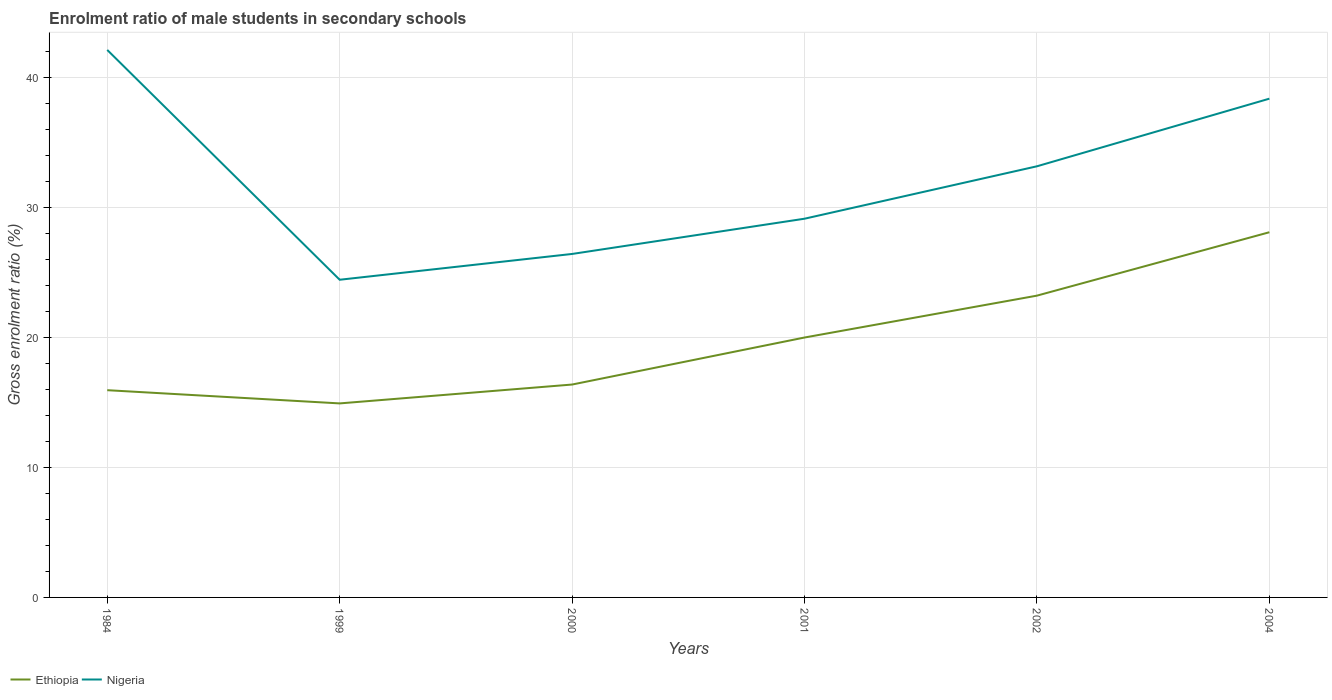How many different coloured lines are there?
Offer a very short reply. 2. Does the line corresponding to Nigeria intersect with the line corresponding to Ethiopia?
Make the answer very short. No. Across all years, what is the maximum enrolment ratio of male students in secondary schools in Nigeria?
Offer a very short reply. 24.42. What is the total enrolment ratio of male students in secondary schools in Ethiopia in the graph?
Ensure brevity in your answer.  -4.05. What is the difference between the highest and the second highest enrolment ratio of male students in secondary schools in Nigeria?
Offer a terse response. 17.67. How many lines are there?
Your response must be concise. 2. How many years are there in the graph?
Your answer should be very brief. 6. What is the difference between two consecutive major ticks on the Y-axis?
Offer a terse response. 10. Does the graph contain any zero values?
Your answer should be very brief. No. Where does the legend appear in the graph?
Your answer should be very brief. Bottom left. How many legend labels are there?
Provide a succinct answer. 2. What is the title of the graph?
Give a very brief answer. Enrolment ratio of male students in secondary schools. What is the label or title of the X-axis?
Your answer should be compact. Years. What is the Gross enrolment ratio (%) of Ethiopia in 1984?
Offer a very short reply. 15.93. What is the Gross enrolment ratio (%) of Nigeria in 1984?
Offer a very short reply. 42.09. What is the Gross enrolment ratio (%) in Ethiopia in 1999?
Provide a succinct answer. 14.92. What is the Gross enrolment ratio (%) in Nigeria in 1999?
Your answer should be very brief. 24.42. What is the Gross enrolment ratio (%) in Ethiopia in 2000?
Give a very brief answer. 16.37. What is the Gross enrolment ratio (%) of Nigeria in 2000?
Offer a terse response. 26.4. What is the Gross enrolment ratio (%) of Ethiopia in 2001?
Offer a very short reply. 19.98. What is the Gross enrolment ratio (%) in Nigeria in 2001?
Your response must be concise. 29.11. What is the Gross enrolment ratio (%) of Ethiopia in 2002?
Ensure brevity in your answer.  23.2. What is the Gross enrolment ratio (%) of Nigeria in 2002?
Offer a very short reply. 33.14. What is the Gross enrolment ratio (%) in Ethiopia in 2004?
Ensure brevity in your answer.  28.07. What is the Gross enrolment ratio (%) in Nigeria in 2004?
Your answer should be compact. 38.34. Across all years, what is the maximum Gross enrolment ratio (%) of Ethiopia?
Provide a short and direct response. 28.07. Across all years, what is the maximum Gross enrolment ratio (%) of Nigeria?
Offer a terse response. 42.09. Across all years, what is the minimum Gross enrolment ratio (%) of Ethiopia?
Provide a short and direct response. 14.92. Across all years, what is the minimum Gross enrolment ratio (%) of Nigeria?
Ensure brevity in your answer.  24.42. What is the total Gross enrolment ratio (%) in Ethiopia in the graph?
Provide a short and direct response. 118.46. What is the total Gross enrolment ratio (%) of Nigeria in the graph?
Your response must be concise. 193.51. What is the difference between the Gross enrolment ratio (%) of Ethiopia in 1984 and that in 1999?
Provide a short and direct response. 1.02. What is the difference between the Gross enrolment ratio (%) in Nigeria in 1984 and that in 1999?
Your answer should be very brief. 17.67. What is the difference between the Gross enrolment ratio (%) in Ethiopia in 1984 and that in 2000?
Make the answer very short. -0.43. What is the difference between the Gross enrolment ratio (%) of Nigeria in 1984 and that in 2000?
Provide a succinct answer. 15.68. What is the difference between the Gross enrolment ratio (%) in Ethiopia in 1984 and that in 2001?
Offer a very short reply. -4.05. What is the difference between the Gross enrolment ratio (%) of Nigeria in 1984 and that in 2001?
Ensure brevity in your answer.  12.98. What is the difference between the Gross enrolment ratio (%) in Ethiopia in 1984 and that in 2002?
Make the answer very short. -7.27. What is the difference between the Gross enrolment ratio (%) in Nigeria in 1984 and that in 2002?
Your answer should be compact. 8.95. What is the difference between the Gross enrolment ratio (%) in Ethiopia in 1984 and that in 2004?
Provide a succinct answer. -12.14. What is the difference between the Gross enrolment ratio (%) of Nigeria in 1984 and that in 2004?
Offer a terse response. 3.75. What is the difference between the Gross enrolment ratio (%) in Ethiopia in 1999 and that in 2000?
Provide a succinct answer. -1.45. What is the difference between the Gross enrolment ratio (%) of Nigeria in 1999 and that in 2000?
Provide a succinct answer. -1.98. What is the difference between the Gross enrolment ratio (%) in Ethiopia in 1999 and that in 2001?
Your answer should be very brief. -5.06. What is the difference between the Gross enrolment ratio (%) of Nigeria in 1999 and that in 2001?
Your response must be concise. -4.69. What is the difference between the Gross enrolment ratio (%) in Ethiopia in 1999 and that in 2002?
Make the answer very short. -8.28. What is the difference between the Gross enrolment ratio (%) of Nigeria in 1999 and that in 2002?
Provide a succinct answer. -8.72. What is the difference between the Gross enrolment ratio (%) of Ethiopia in 1999 and that in 2004?
Provide a short and direct response. -13.16. What is the difference between the Gross enrolment ratio (%) of Nigeria in 1999 and that in 2004?
Your answer should be very brief. -13.92. What is the difference between the Gross enrolment ratio (%) of Ethiopia in 2000 and that in 2001?
Your answer should be compact. -3.61. What is the difference between the Gross enrolment ratio (%) in Nigeria in 2000 and that in 2001?
Provide a succinct answer. -2.71. What is the difference between the Gross enrolment ratio (%) of Ethiopia in 2000 and that in 2002?
Give a very brief answer. -6.83. What is the difference between the Gross enrolment ratio (%) in Nigeria in 2000 and that in 2002?
Provide a succinct answer. -6.74. What is the difference between the Gross enrolment ratio (%) in Ethiopia in 2000 and that in 2004?
Your answer should be very brief. -11.71. What is the difference between the Gross enrolment ratio (%) of Nigeria in 2000 and that in 2004?
Give a very brief answer. -11.94. What is the difference between the Gross enrolment ratio (%) in Ethiopia in 2001 and that in 2002?
Give a very brief answer. -3.22. What is the difference between the Gross enrolment ratio (%) of Nigeria in 2001 and that in 2002?
Offer a very short reply. -4.03. What is the difference between the Gross enrolment ratio (%) in Ethiopia in 2001 and that in 2004?
Make the answer very short. -8.09. What is the difference between the Gross enrolment ratio (%) of Nigeria in 2001 and that in 2004?
Your response must be concise. -9.23. What is the difference between the Gross enrolment ratio (%) in Ethiopia in 2002 and that in 2004?
Your response must be concise. -4.87. What is the difference between the Gross enrolment ratio (%) in Nigeria in 2002 and that in 2004?
Offer a very short reply. -5.2. What is the difference between the Gross enrolment ratio (%) in Ethiopia in 1984 and the Gross enrolment ratio (%) in Nigeria in 1999?
Your response must be concise. -8.49. What is the difference between the Gross enrolment ratio (%) of Ethiopia in 1984 and the Gross enrolment ratio (%) of Nigeria in 2000?
Your response must be concise. -10.47. What is the difference between the Gross enrolment ratio (%) in Ethiopia in 1984 and the Gross enrolment ratio (%) in Nigeria in 2001?
Your response must be concise. -13.18. What is the difference between the Gross enrolment ratio (%) of Ethiopia in 1984 and the Gross enrolment ratio (%) of Nigeria in 2002?
Offer a very short reply. -17.21. What is the difference between the Gross enrolment ratio (%) in Ethiopia in 1984 and the Gross enrolment ratio (%) in Nigeria in 2004?
Offer a terse response. -22.41. What is the difference between the Gross enrolment ratio (%) in Ethiopia in 1999 and the Gross enrolment ratio (%) in Nigeria in 2000?
Keep it short and to the point. -11.49. What is the difference between the Gross enrolment ratio (%) of Ethiopia in 1999 and the Gross enrolment ratio (%) of Nigeria in 2001?
Provide a short and direct response. -14.2. What is the difference between the Gross enrolment ratio (%) in Ethiopia in 1999 and the Gross enrolment ratio (%) in Nigeria in 2002?
Your answer should be compact. -18.23. What is the difference between the Gross enrolment ratio (%) of Ethiopia in 1999 and the Gross enrolment ratio (%) of Nigeria in 2004?
Provide a succinct answer. -23.43. What is the difference between the Gross enrolment ratio (%) of Ethiopia in 2000 and the Gross enrolment ratio (%) of Nigeria in 2001?
Keep it short and to the point. -12.75. What is the difference between the Gross enrolment ratio (%) of Ethiopia in 2000 and the Gross enrolment ratio (%) of Nigeria in 2002?
Offer a very short reply. -16.78. What is the difference between the Gross enrolment ratio (%) of Ethiopia in 2000 and the Gross enrolment ratio (%) of Nigeria in 2004?
Provide a short and direct response. -21.98. What is the difference between the Gross enrolment ratio (%) of Ethiopia in 2001 and the Gross enrolment ratio (%) of Nigeria in 2002?
Your response must be concise. -13.16. What is the difference between the Gross enrolment ratio (%) in Ethiopia in 2001 and the Gross enrolment ratio (%) in Nigeria in 2004?
Your answer should be compact. -18.36. What is the difference between the Gross enrolment ratio (%) of Ethiopia in 2002 and the Gross enrolment ratio (%) of Nigeria in 2004?
Make the answer very short. -15.14. What is the average Gross enrolment ratio (%) of Ethiopia per year?
Your answer should be compact. 19.74. What is the average Gross enrolment ratio (%) of Nigeria per year?
Keep it short and to the point. 32.25. In the year 1984, what is the difference between the Gross enrolment ratio (%) of Ethiopia and Gross enrolment ratio (%) of Nigeria?
Your answer should be very brief. -26.16. In the year 1999, what is the difference between the Gross enrolment ratio (%) of Ethiopia and Gross enrolment ratio (%) of Nigeria?
Your response must be concise. -9.51. In the year 2000, what is the difference between the Gross enrolment ratio (%) in Ethiopia and Gross enrolment ratio (%) in Nigeria?
Offer a terse response. -10.04. In the year 2001, what is the difference between the Gross enrolment ratio (%) in Ethiopia and Gross enrolment ratio (%) in Nigeria?
Your answer should be very brief. -9.13. In the year 2002, what is the difference between the Gross enrolment ratio (%) in Ethiopia and Gross enrolment ratio (%) in Nigeria?
Ensure brevity in your answer.  -9.94. In the year 2004, what is the difference between the Gross enrolment ratio (%) of Ethiopia and Gross enrolment ratio (%) of Nigeria?
Provide a short and direct response. -10.27. What is the ratio of the Gross enrolment ratio (%) in Ethiopia in 1984 to that in 1999?
Offer a terse response. 1.07. What is the ratio of the Gross enrolment ratio (%) in Nigeria in 1984 to that in 1999?
Keep it short and to the point. 1.72. What is the ratio of the Gross enrolment ratio (%) in Ethiopia in 1984 to that in 2000?
Offer a terse response. 0.97. What is the ratio of the Gross enrolment ratio (%) of Nigeria in 1984 to that in 2000?
Make the answer very short. 1.59. What is the ratio of the Gross enrolment ratio (%) of Ethiopia in 1984 to that in 2001?
Ensure brevity in your answer.  0.8. What is the ratio of the Gross enrolment ratio (%) in Nigeria in 1984 to that in 2001?
Make the answer very short. 1.45. What is the ratio of the Gross enrolment ratio (%) of Ethiopia in 1984 to that in 2002?
Provide a succinct answer. 0.69. What is the ratio of the Gross enrolment ratio (%) in Nigeria in 1984 to that in 2002?
Offer a very short reply. 1.27. What is the ratio of the Gross enrolment ratio (%) of Ethiopia in 1984 to that in 2004?
Provide a short and direct response. 0.57. What is the ratio of the Gross enrolment ratio (%) of Nigeria in 1984 to that in 2004?
Provide a succinct answer. 1.1. What is the ratio of the Gross enrolment ratio (%) of Ethiopia in 1999 to that in 2000?
Provide a short and direct response. 0.91. What is the ratio of the Gross enrolment ratio (%) in Nigeria in 1999 to that in 2000?
Ensure brevity in your answer.  0.92. What is the ratio of the Gross enrolment ratio (%) in Ethiopia in 1999 to that in 2001?
Offer a terse response. 0.75. What is the ratio of the Gross enrolment ratio (%) in Nigeria in 1999 to that in 2001?
Keep it short and to the point. 0.84. What is the ratio of the Gross enrolment ratio (%) of Ethiopia in 1999 to that in 2002?
Your response must be concise. 0.64. What is the ratio of the Gross enrolment ratio (%) of Nigeria in 1999 to that in 2002?
Make the answer very short. 0.74. What is the ratio of the Gross enrolment ratio (%) in Ethiopia in 1999 to that in 2004?
Provide a short and direct response. 0.53. What is the ratio of the Gross enrolment ratio (%) of Nigeria in 1999 to that in 2004?
Your answer should be very brief. 0.64. What is the ratio of the Gross enrolment ratio (%) of Ethiopia in 2000 to that in 2001?
Offer a very short reply. 0.82. What is the ratio of the Gross enrolment ratio (%) of Nigeria in 2000 to that in 2001?
Keep it short and to the point. 0.91. What is the ratio of the Gross enrolment ratio (%) of Ethiopia in 2000 to that in 2002?
Offer a very short reply. 0.71. What is the ratio of the Gross enrolment ratio (%) of Nigeria in 2000 to that in 2002?
Keep it short and to the point. 0.8. What is the ratio of the Gross enrolment ratio (%) in Ethiopia in 2000 to that in 2004?
Keep it short and to the point. 0.58. What is the ratio of the Gross enrolment ratio (%) of Nigeria in 2000 to that in 2004?
Your answer should be very brief. 0.69. What is the ratio of the Gross enrolment ratio (%) in Ethiopia in 2001 to that in 2002?
Keep it short and to the point. 0.86. What is the ratio of the Gross enrolment ratio (%) in Nigeria in 2001 to that in 2002?
Make the answer very short. 0.88. What is the ratio of the Gross enrolment ratio (%) in Ethiopia in 2001 to that in 2004?
Give a very brief answer. 0.71. What is the ratio of the Gross enrolment ratio (%) of Nigeria in 2001 to that in 2004?
Give a very brief answer. 0.76. What is the ratio of the Gross enrolment ratio (%) of Ethiopia in 2002 to that in 2004?
Ensure brevity in your answer.  0.83. What is the ratio of the Gross enrolment ratio (%) in Nigeria in 2002 to that in 2004?
Your answer should be compact. 0.86. What is the difference between the highest and the second highest Gross enrolment ratio (%) of Ethiopia?
Offer a terse response. 4.87. What is the difference between the highest and the second highest Gross enrolment ratio (%) of Nigeria?
Offer a terse response. 3.75. What is the difference between the highest and the lowest Gross enrolment ratio (%) in Ethiopia?
Ensure brevity in your answer.  13.16. What is the difference between the highest and the lowest Gross enrolment ratio (%) in Nigeria?
Keep it short and to the point. 17.67. 